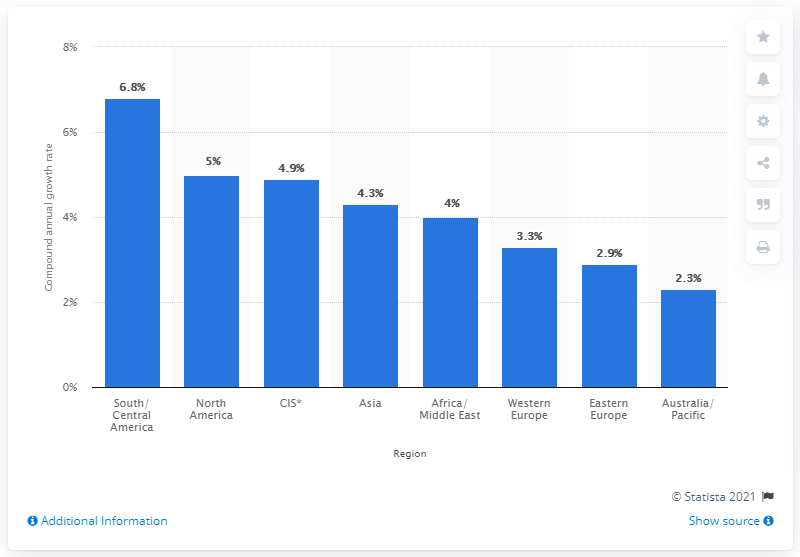Mention a couple of crucial points in this snapshot. The global railway technology market is expected to experience an annual growth rate of 6.8% from 2021 to 2028. 